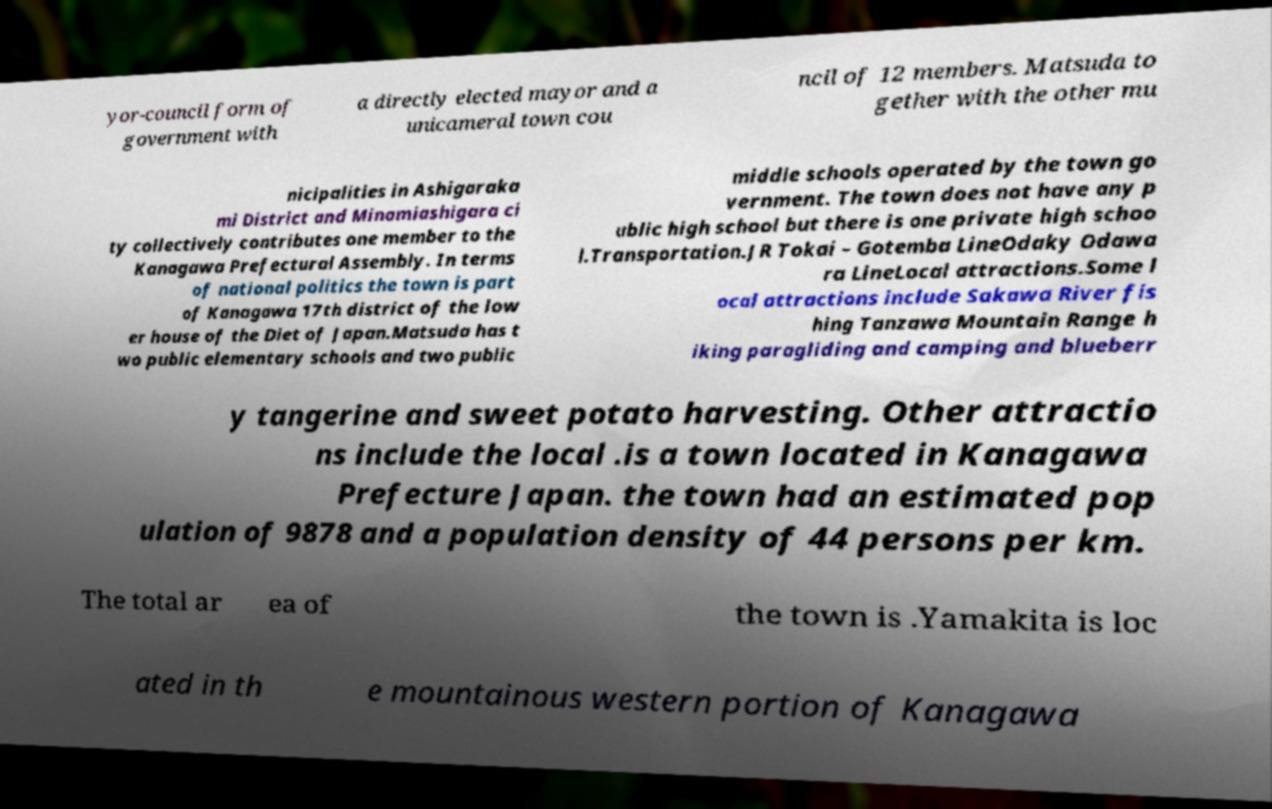Please read and relay the text visible in this image. What does it say? yor-council form of government with a directly elected mayor and a unicameral town cou ncil of 12 members. Matsuda to gether with the other mu nicipalities in Ashigaraka mi District and Minamiashigara ci ty collectively contributes one member to the Kanagawa Prefectural Assembly. In terms of national politics the town is part of Kanagawa 17th district of the low er house of the Diet of Japan.Matsuda has t wo public elementary schools and two public middle schools operated by the town go vernment. The town does not have any p ublic high school but there is one private high schoo l.Transportation.JR Tokai – Gotemba LineOdaky Odawa ra LineLocal attractions.Some l ocal attractions include Sakawa River fis hing Tanzawa Mountain Range h iking paragliding and camping and blueberr y tangerine and sweet potato harvesting. Other attractio ns include the local .is a town located in Kanagawa Prefecture Japan. the town had an estimated pop ulation of 9878 and a population density of 44 persons per km. The total ar ea of the town is .Yamakita is loc ated in th e mountainous western portion of Kanagawa 